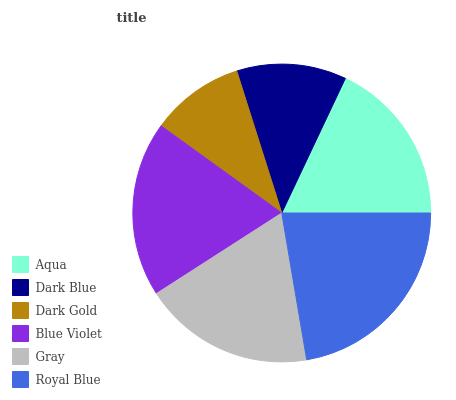Is Dark Gold the minimum?
Answer yes or no. Yes. Is Royal Blue the maximum?
Answer yes or no. Yes. Is Dark Blue the minimum?
Answer yes or no. No. Is Dark Blue the maximum?
Answer yes or no. No. Is Aqua greater than Dark Blue?
Answer yes or no. Yes. Is Dark Blue less than Aqua?
Answer yes or no. Yes. Is Dark Blue greater than Aqua?
Answer yes or no. No. Is Aqua less than Dark Blue?
Answer yes or no. No. Is Gray the high median?
Answer yes or no. Yes. Is Aqua the low median?
Answer yes or no. Yes. Is Blue Violet the high median?
Answer yes or no. No. Is Dark Blue the low median?
Answer yes or no. No. 